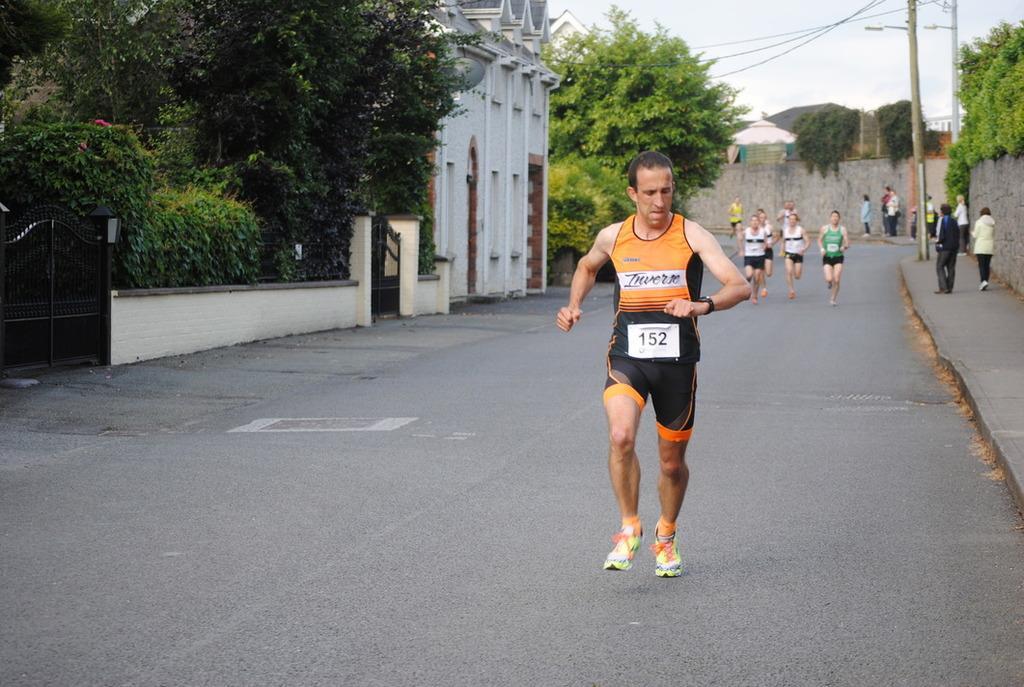Please provide a concise description of this image. In the image in the center we can see few peoples were running on the road and they were in different color t shirts. In the background we can see sky,buildings,wall,gate,fence,trees,road and few people standing. 